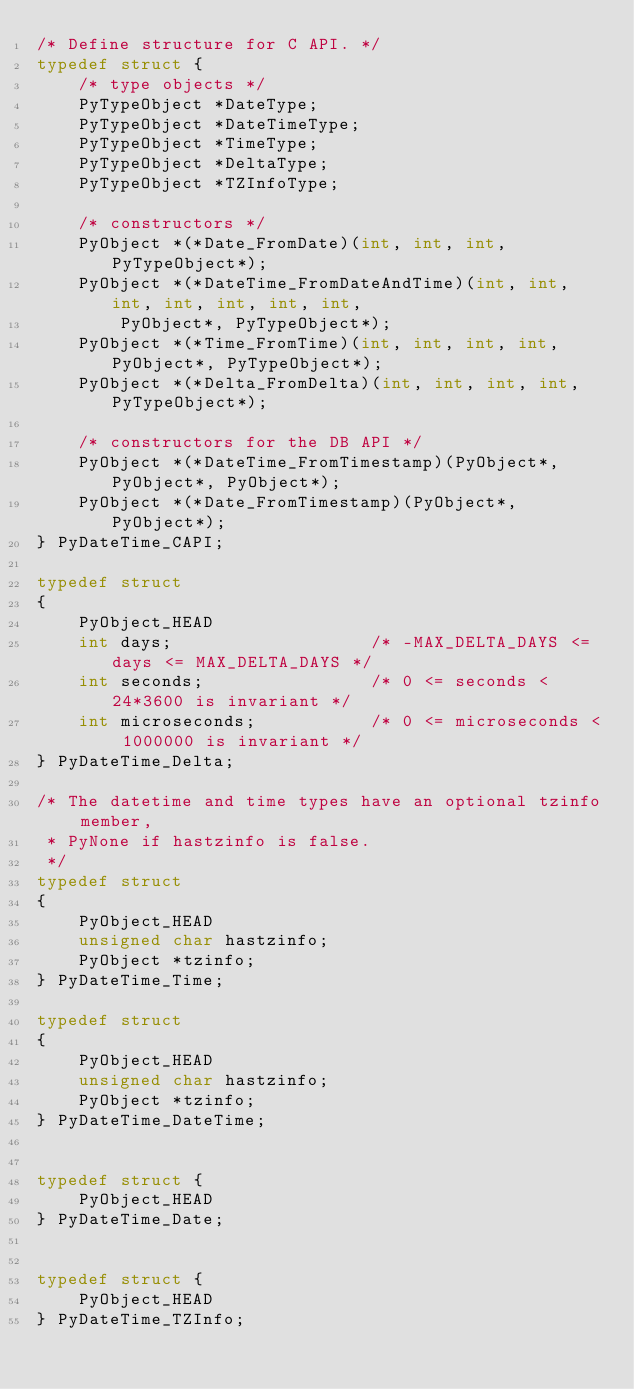<code> <loc_0><loc_0><loc_500><loc_500><_C_>/* Define structure for C API. */
typedef struct {
    /* type objects */
    PyTypeObject *DateType;
    PyTypeObject *DateTimeType;
    PyTypeObject *TimeType;
    PyTypeObject *DeltaType;
    PyTypeObject *TZInfoType;

    /* constructors */
    PyObject *(*Date_FromDate)(int, int, int, PyTypeObject*);
    PyObject *(*DateTime_FromDateAndTime)(int, int, int, int, int, int, int,
        PyObject*, PyTypeObject*);
    PyObject *(*Time_FromTime)(int, int, int, int, PyObject*, PyTypeObject*);
    PyObject *(*Delta_FromDelta)(int, int, int, int, PyTypeObject*);

    /* constructors for the DB API */
    PyObject *(*DateTime_FromTimestamp)(PyObject*, PyObject*, PyObject*);
    PyObject *(*Date_FromTimestamp)(PyObject*, PyObject*);
} PyDateTime_CAPI;

typedef struct
{
    PyObject_HEAD
    int days;                   /* -MAX_DELTA_DAYS <= days <= MAX_DELTA_DAYS */
    int seconds;                /* 0 <= seconds < 24*3600 is invariant */
    int microseconds;           /* 0 <= microseconds < 1000000 is invariant */
} PyDateTime_Delta;

/* The datetime and time types have an optional tzinfo member,
 * PyNone if hastzinfo is false.
 */
typedef struct
{
    PyObject_HEAD
    unsigned char hastzinfo;
    PyObject *tzinfo;
} PyDateTime_Time;

typedef struct
{
    PyObject_HEAD
    unsigned char hastzinfo;
    PyObject *tzinfo;
} PyDateTime_DateTime;


typedef struct {
    PyObject_HEAD
} PyDateTime_Date;


typedef struct {
    PyObject_HEAD
} PyDateTime_TZInfo;

</code> 